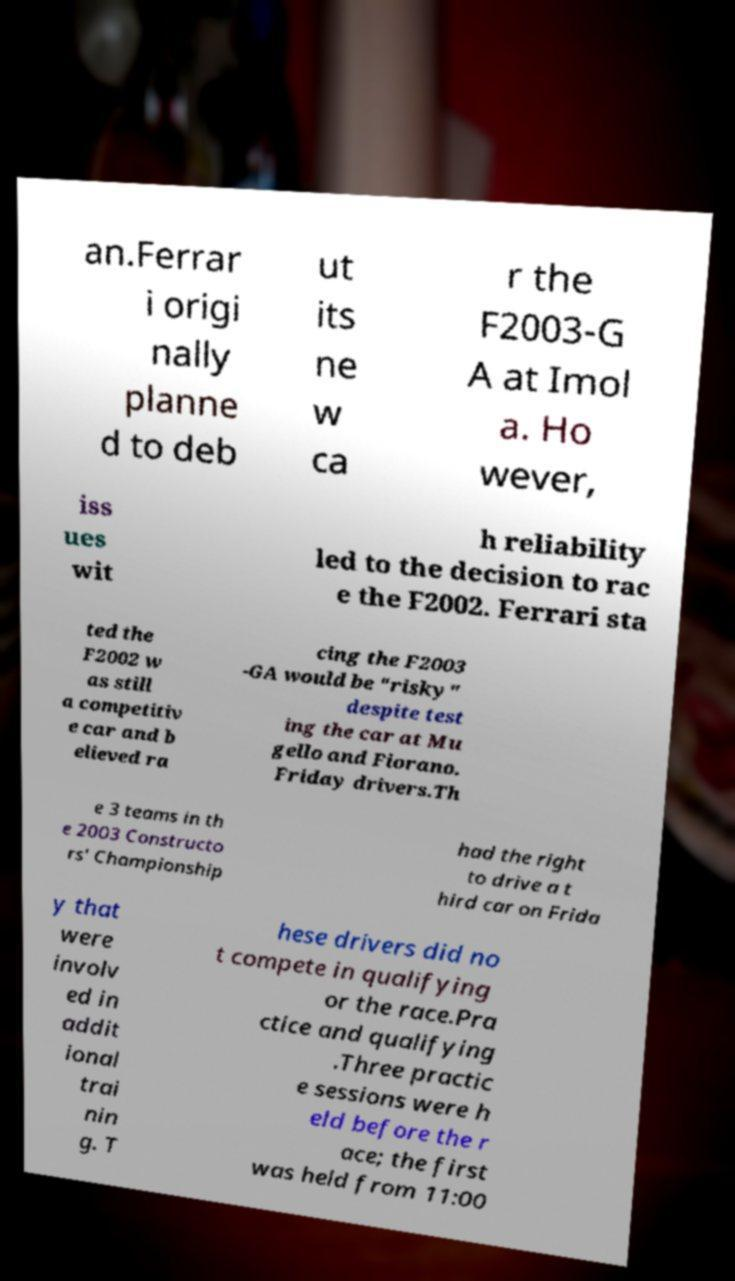I need the written content from this picture converted into text. Can you do that? an.Ferrar i origi nally planne d to deb ut its ne w ca r the F2003-G A at Imol a. Ho wever, iss ues wit h reliability led to the decision to rac e the F2002. Ferrari sta ted the F2002 w as still a competitiv e car and b elieved ra cing the F2003 -GA would be "risky" despite test ing the car at Mu gello and Fiorano. Friday drivers.Th e 3 teams in th e 2003 Constructo rs' Championship had the right to drive a t hird car on Frida y that were involv ed in addit ional trai nin g. T hese drivers did no t compete in qualifying or the race.Pra ctice and qualifying .Three practic e sessions were h eld before the r ace; the first was held from 11:00 